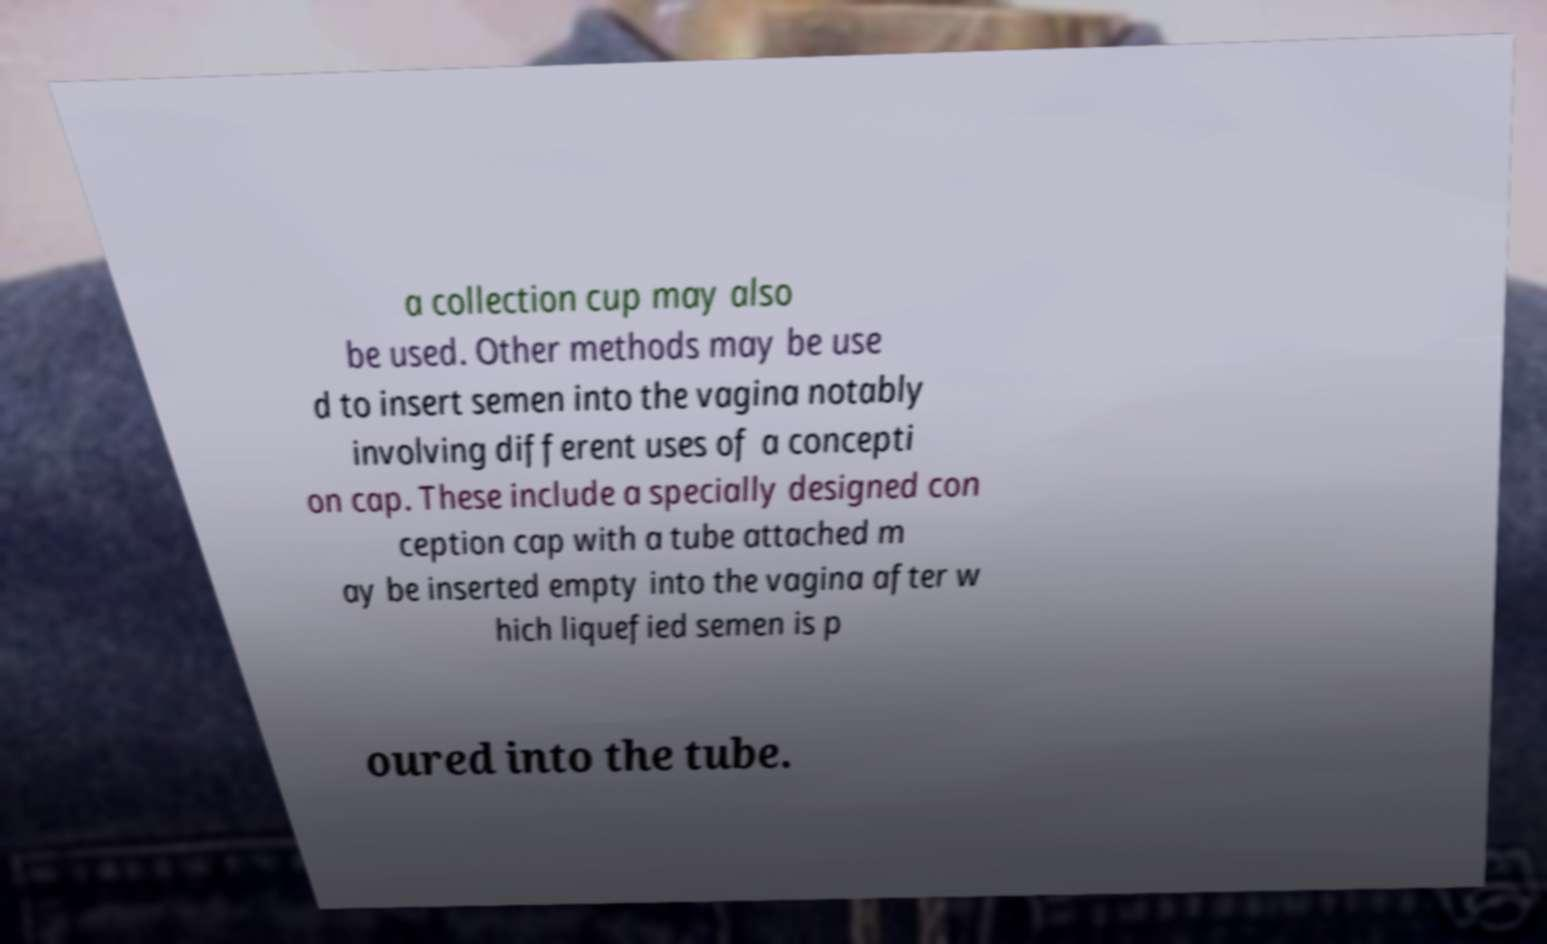Could you assist in decoding the text presented in this image and type it out clearly? a collection cup may also be used. Other methods may be use d to insert semen into the vagina notably involving different uses of a concepti on cap. These include a specially designed con ception cap with a tube attached m ay be inserted empty into the vagina after w hich liquefied semen is p oured into the tube. 